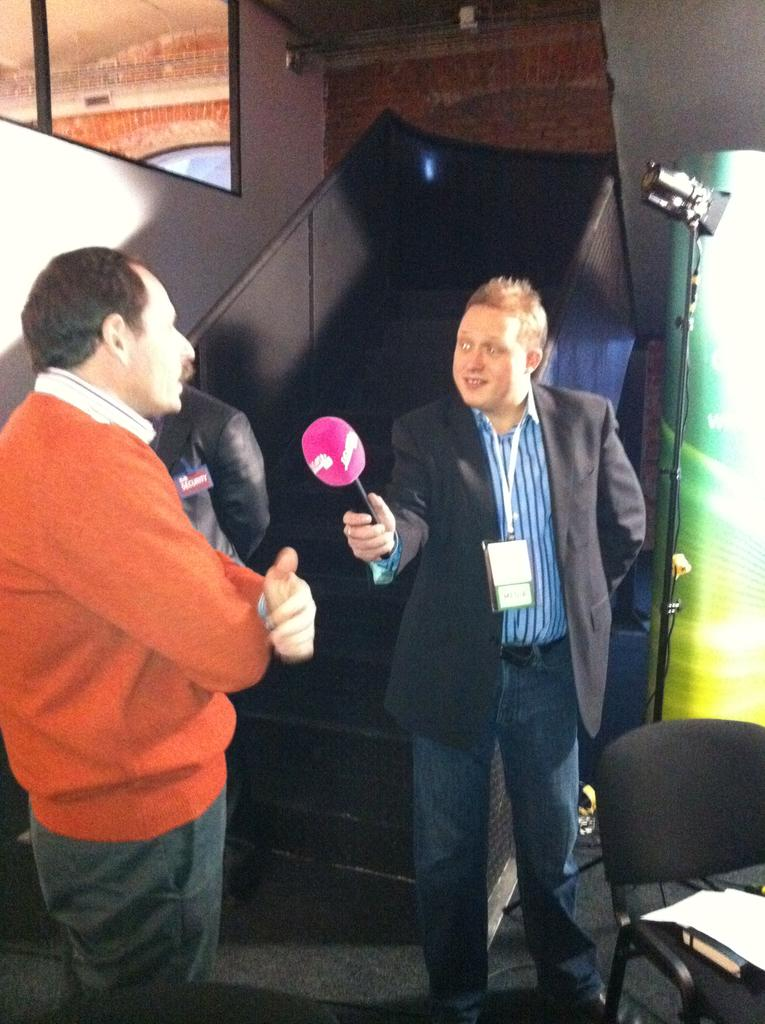How many people are present in the image? There are three people in the image. What is one of the people doing in the image? One of the people is holding a microphone. Can you describe the expression of the person holding the microphone? The person holding the microphone is smiling. What is the primary surface visible in the image? There is a floor in the image. What architectural features can be seen in the background of the image? There are steps, a window, and a wall in the background of the image. What type of jeans is the zebra wearing in the image? There is no zebra present in the image, and therefore no one is wearing jeans. What type of fan can be seen in the image? There is no fan visible in the image. 